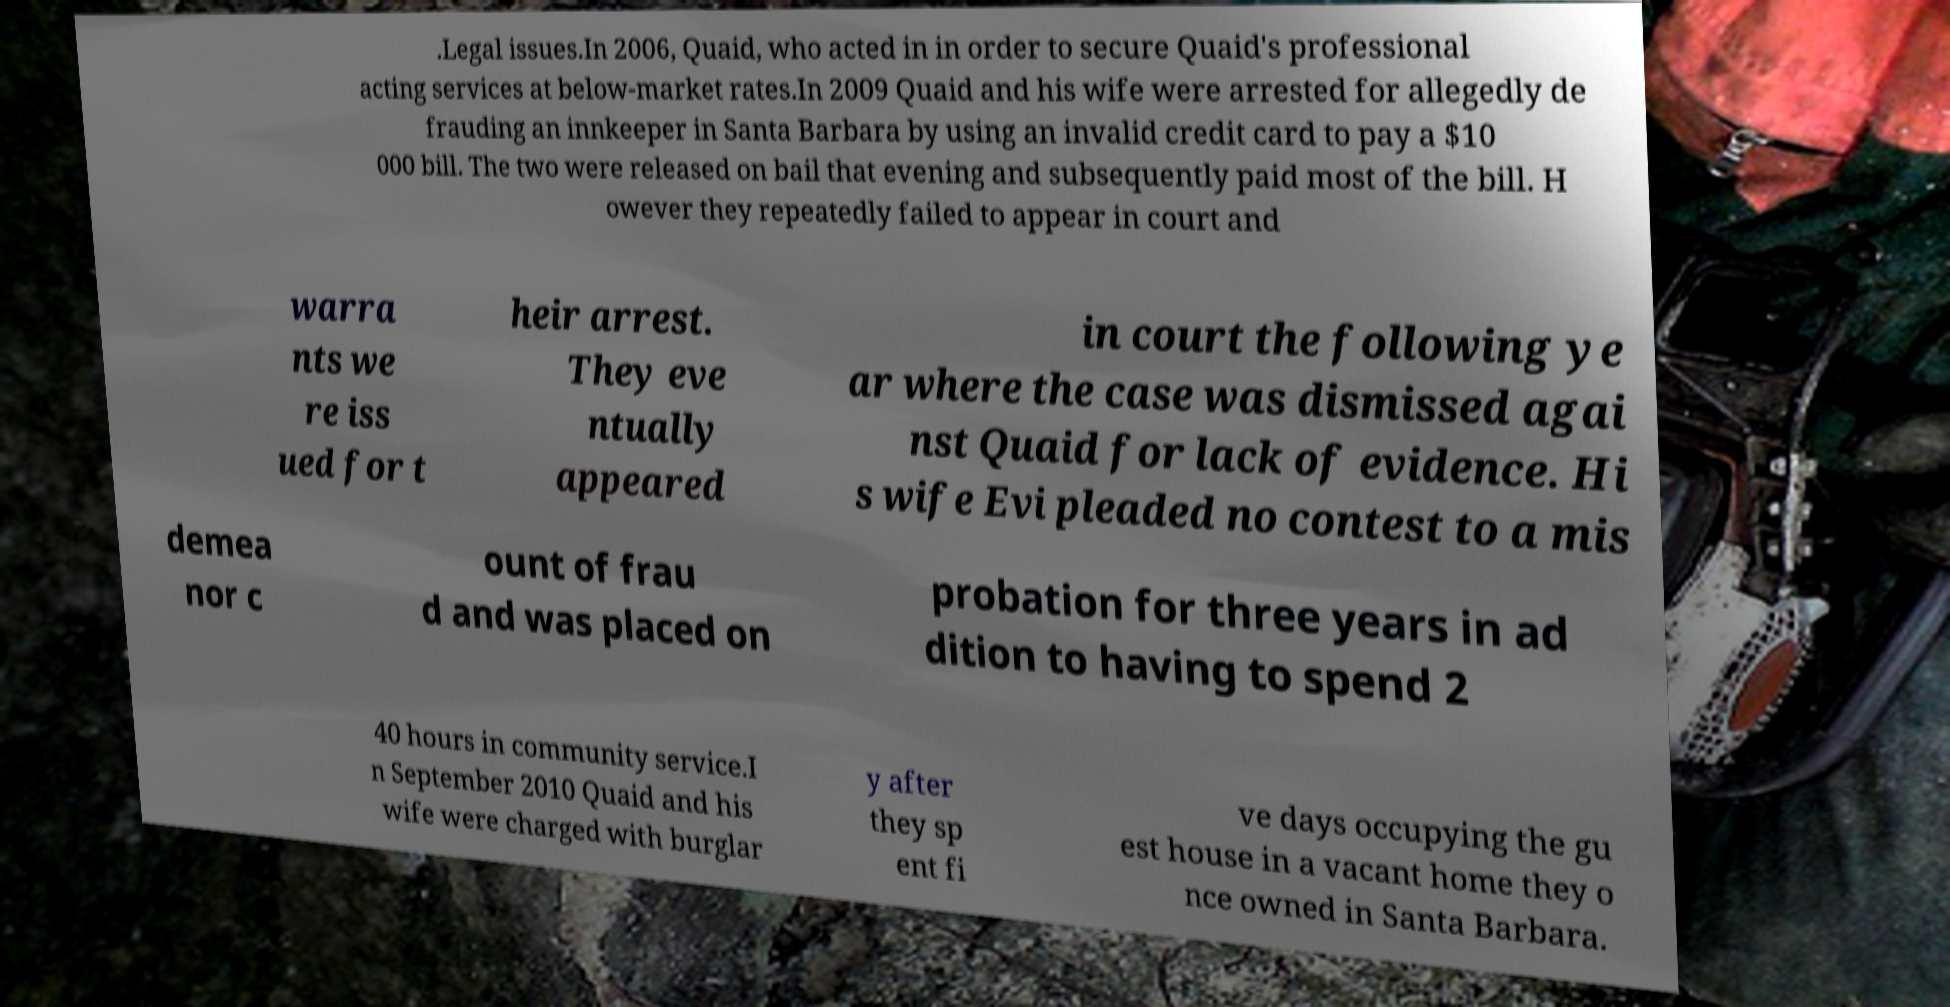Can you accurately transcribe the text from the provided image for me? .Legal issues.In 2006, Quaid, who acted in in order to secure Quaid's professional acting services at below-market rates.In 2009 Quaid and his wife were arrested for allegedly de frauding an innkeeper in Santa Barbara by using an invalid credit card to pay a $10 000 bill. The two were released on bail that evening and subsequently paid most of the bill. H owever they repeatedly failed to appear in court and warra nts we re iss ued for t heir arrest. They eve ntually appeared in court the following ye ar where the case was dismissed agai nst Quaid for lack of evidence. Hi s wife Evi pleaded no contest to a mis demea nor c ount of frau d and was placed on probation for three years in ad dition to having to spend 2 40 hours in community service.I n September 2010 Quaid and his wife were charged with burglar y after they sp ent fi ve days occupying the gu est house in a vacant home they o nce owned in Santa Barbara. 